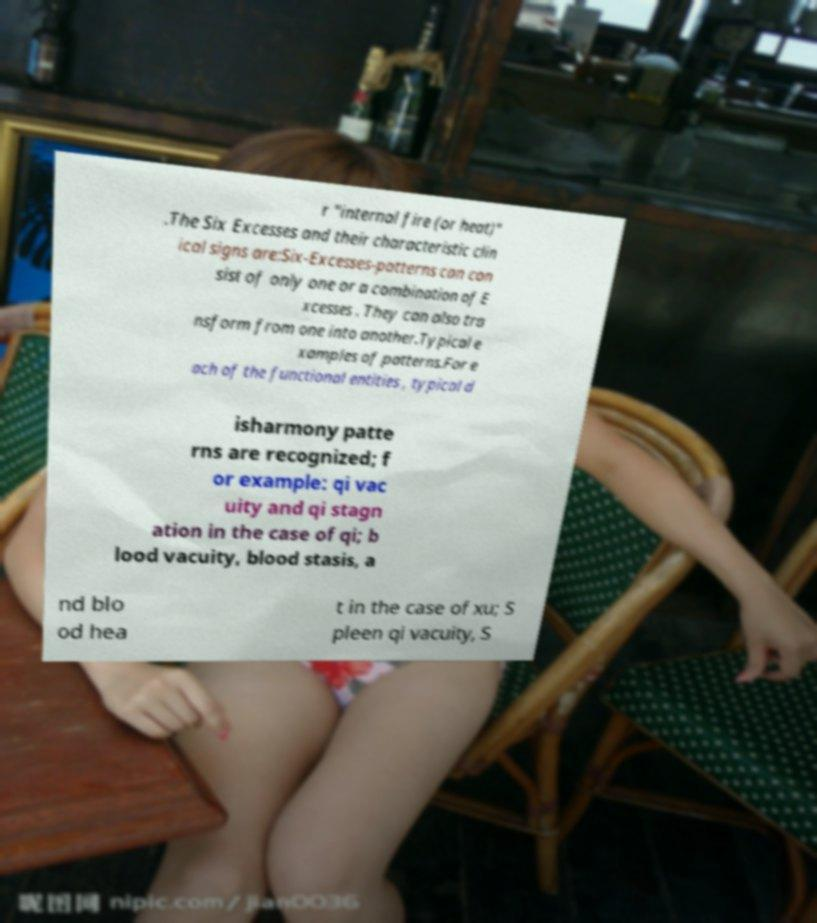Can you accurately transcribe the text from the provided image for me? r "internal fire (or heat)" .The Six Excesses and their characteristic clin ical signs are:Six-Excesses-patterns can con sist of only one or a combination of E xcesses . They can also tra nsform from one into another.Typical e xamples of patterns.For e ach of the functional entities , typical d isharmony patte rns are recognized; f or example: qi vac uity and qi stagn ation in the case of qi; b lood vacuity, blood stasis, a nd blo od hea t in the case of xu; S pleen qi vacuity, S 